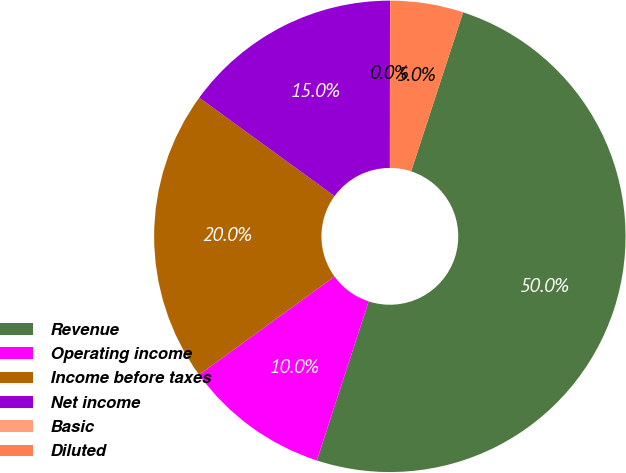Convert chart. <chart><loc_0><loc_0><loc_500><loc_500><pie_chart><fcel>Revenue<fcel>Operating income<fcel>Income before taxes<fcel>Net income<fcel>Basic<fcel>Diluted<nl><fcel>49.98%<fcel>10.0%<fcel>20.0%<fcel>15.0%<fcel>0.01%<fcel>5.01%<nl></chart> 